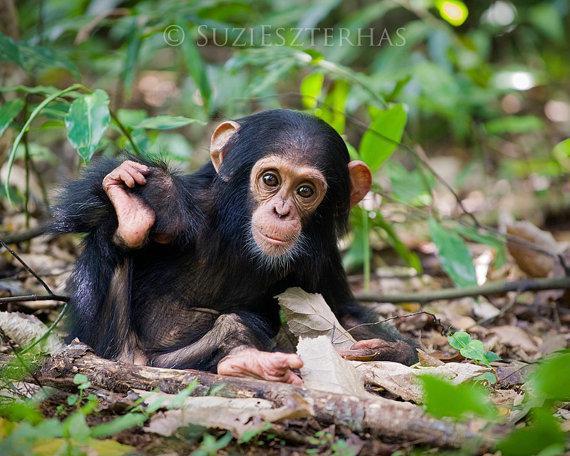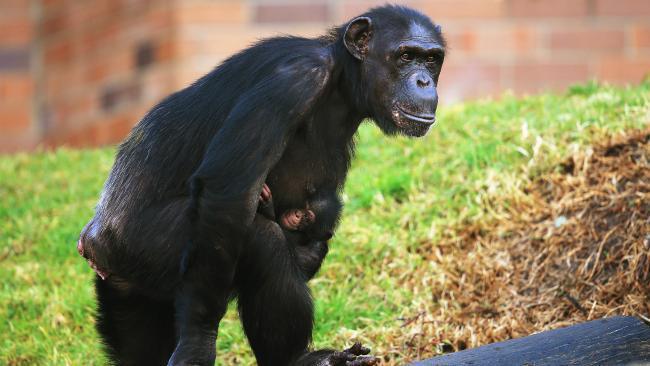The first image is the image on the left, the second image is the image on the right. Considering the images on both sides, is "The left image contains exactly two chimpanzees." valid? Answer yes or no. No. The first image is the image on the left, the second image is the image on the right. Assess this claim about the two images: "There are three or fewer apes in total.". Correct or not? Answer yes or no. Yes. 